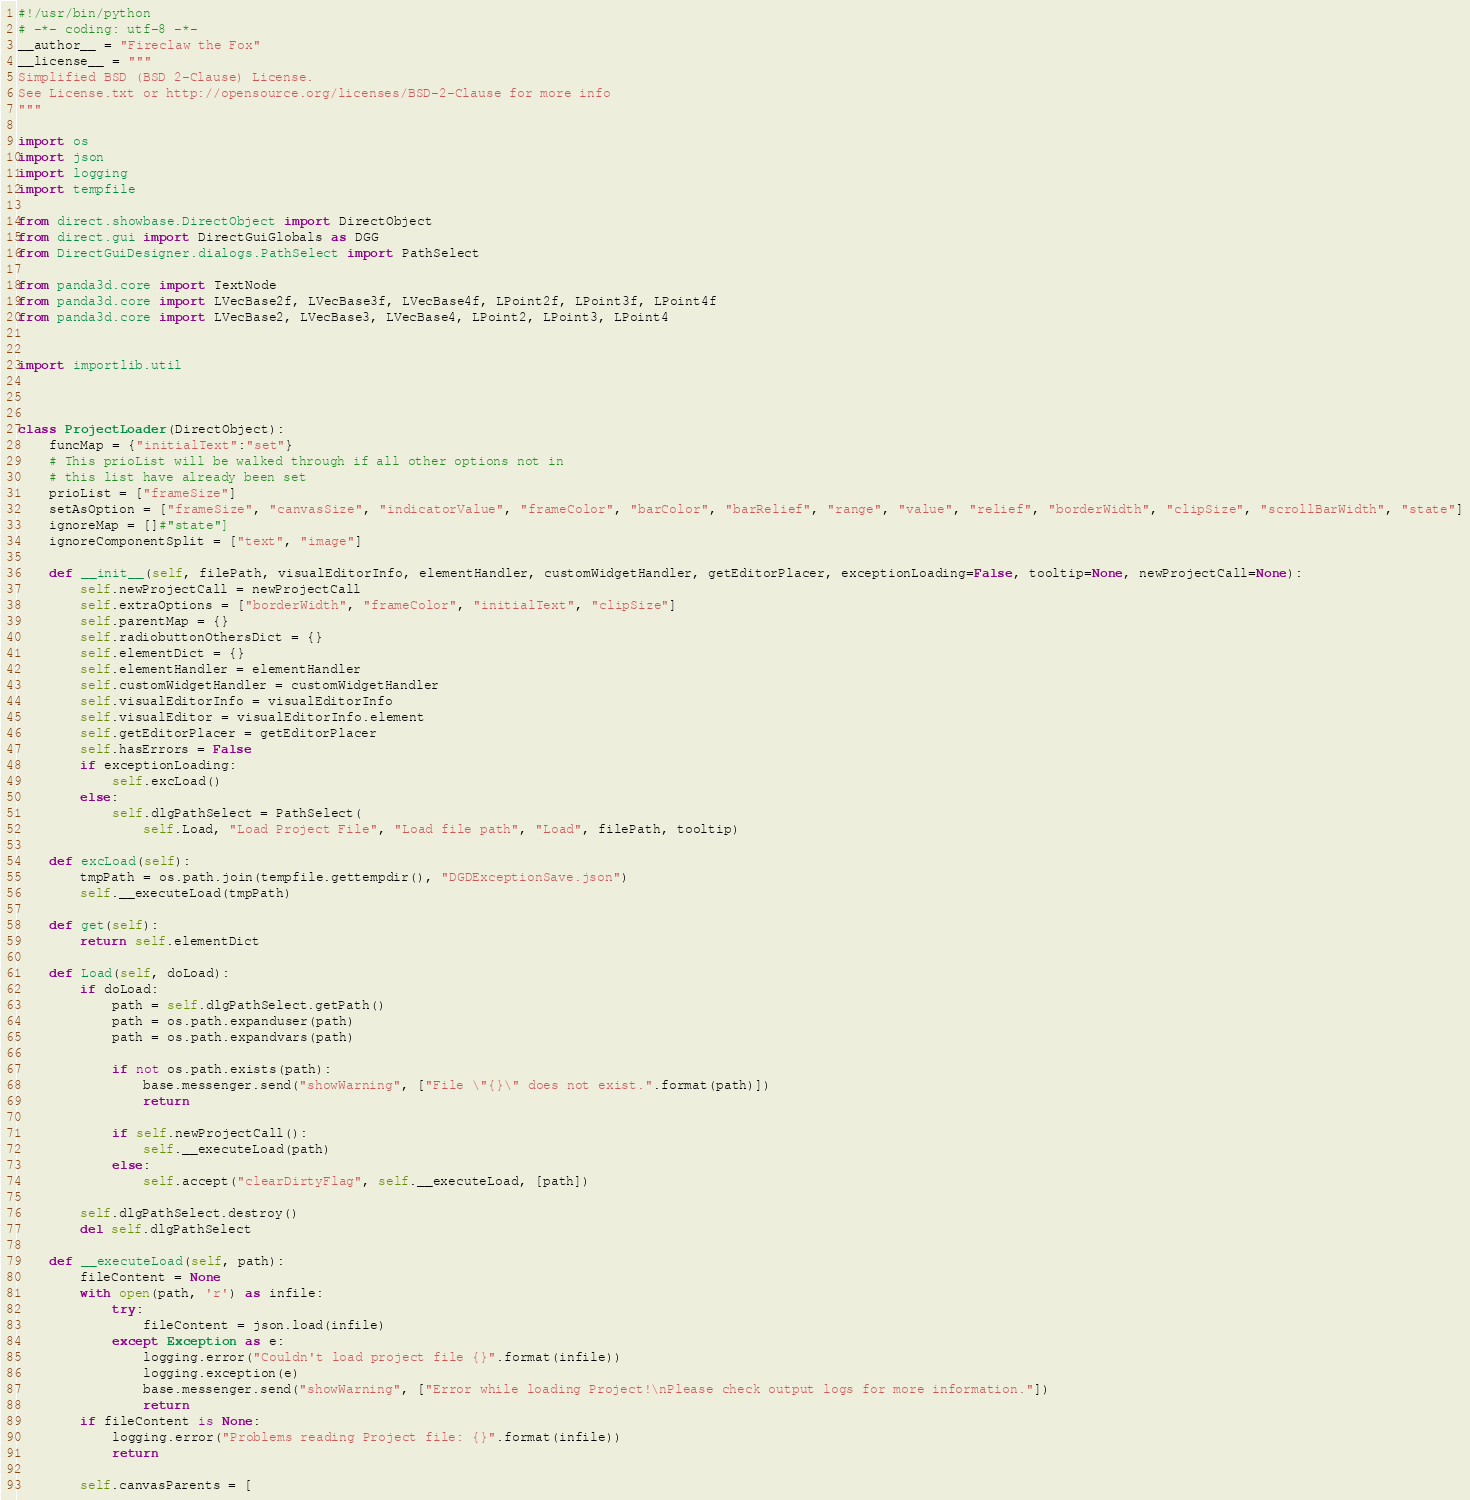Convert code to text. <code><loc_0><loc_0><loc_500><loc_500><_Python_>#!/usr/bin/python
# -*- coding: utf-8 -*-
__author__ = "Fireclaw the Fox"
__license__ = """
Simplified BSD (BSD 2-Clause) License.
See License.txt or http://opensource.org/licenses/BSD-2-Clause for more info
"""

import os
import json
import logging
import tempfile

from direct.showbase.DirectObject import DirectObject
from direct.gui import DirectGuiGlobals as DGG
from DirectGuiDesigner.dialogs.PathSelect import PathSelect

from panda3d.core import TextNode
from panda3d.core import LVecBase2f, LVecBase3f, LVecBase4f, LPoint2f, LPoint3f, LPoint4f
from panda3d.core import LVecBase2, LVecBase3, LVecBase4, LPoint2, LPoint3, LPoint4


import importlib.util



class ProjectLoader(DirectObject):
    funcMap = {"initialText":"set"}
    # This prioList will be walked through if all other options not in
    # this list have already been set
    prioList = ["frameSize"]
    setAsOption = ["frameSize", "canvasSize", "indicatorValue", "frameColor", "barColor", "barRelief", "range", "value", "relief", "borderWidth", "clipSize", "scrollBarWidth", "state"]
    ignoreMap = []#"state"]
    ignoreComponentSplit = ["text", "image"]

    def __init__(self, filePath, visualEditorInfo, elementHandler, customWidgetHandler, getEditorPlacer, exceptionLoading=False, tooltip=None, newProjectCall=None):
        self.newProjectCall = newProjectCall
        self.extraOptions = ["borderWidth", "frameColor", "initialText", "clipSize"]
        self.parentMap = {}
        self.radiobuttonOthersDict = {}
        self.elementDict = {}
        self.elementHandler = elementHandler
        self.customWidgetHandler = customWidgetHandler
        self.visualEditorInfo = visualEditorInfo
        self.visualEditor = visualEditorInfo.element
        self.getEditorPlacer = getEditorPlacer
        self.hasErrors = False
        if exceptionLoading:
            self.excLoad()
        else:
            self.dlgPathSelect = PathSelect(
                self.Load, "Load Project File", "Load file path", "Load", filePath, tooltip)

    def excLoad(self):
        tmpPath = os.path.join(tempfile.gettempdir(), "DGDExceptionSave.json")
        self.__executeLoad(tmpPath)

    def get(self):
        return self.elementDict

    def Load(self, doLoad):
        if doLoad:
            path = self.dlgPathSelect.getPath()
            path = os.path.expanduser(path)
            path = os.path.expandvars(path)

            if not os.path.exists(path):
                base.messenger.send("showWarning", ["File \"{}\" does not exist.".format(path)])
                return

            if self.newProjectCall():
                self.__executeLoad(path)
            else:
                self.accept("clearDirtyFlag", self.__executeLoad, [path])

        self.dlgPathSelect.destroy()
        del self.dlgPathSelect

    def __executeLoad(self, path):
        fileContent = None
        with open(path, 'r') as infile:
            try:
                fileContent = json.load(infile)
            except Exception as e:
                logging.error("Couldn't load project file {}".format(infile))
                logging.exception(e)
                base.messenger.send("showWarning", ["Error while loading Project!\nPlease check output logs for more information."])
                return
        if fileContent is None:
            logging.error("Problems reading Project file: {}".format(infile))
            return

        self.canvasParents = [</code> 